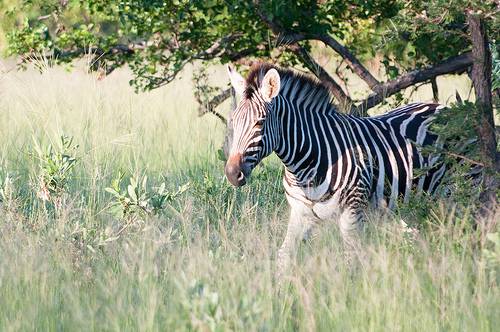Please provide a short description for this region: [0.43, 0.28, 0.59, 0.38]. The region defined by the coordinates [0.43, 0.28, 0.59, 0.38] includes the two ears on the zebra, which are pointy and distinct within the frame. 